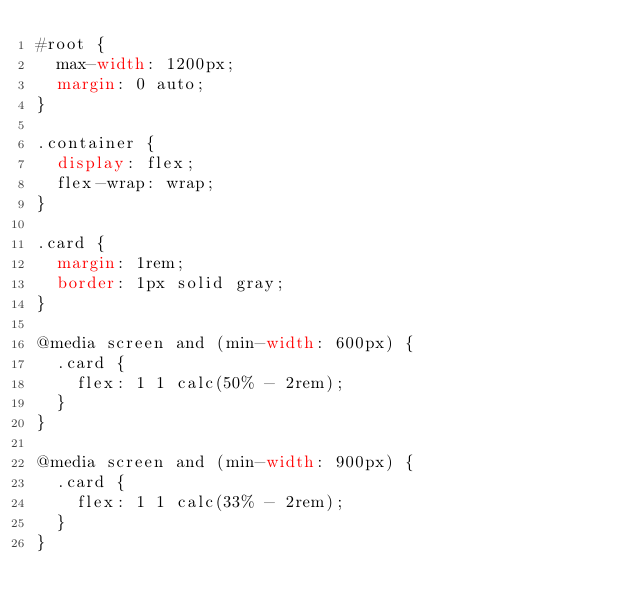Convert code to text. <code><loc_0><loc_0><loc_500><loc_500><_CSS_>#root {
  max-width: 1200px;
  margin: 0 auto;
}

.container {
  display: flex;
  flex-wrap: wrap;
}

.card {
  margin: 1rem;
  border: 1px solid gray;
}

@media screen and (min-width: 600px) {
  .card {
    flex: 1 1 calc(50% - 2rem);
  }
}

@media screen and (min-width: 900px) {
  .card {
    flex: 1 1 calc(33% - 2rem);
  }
}</code> 